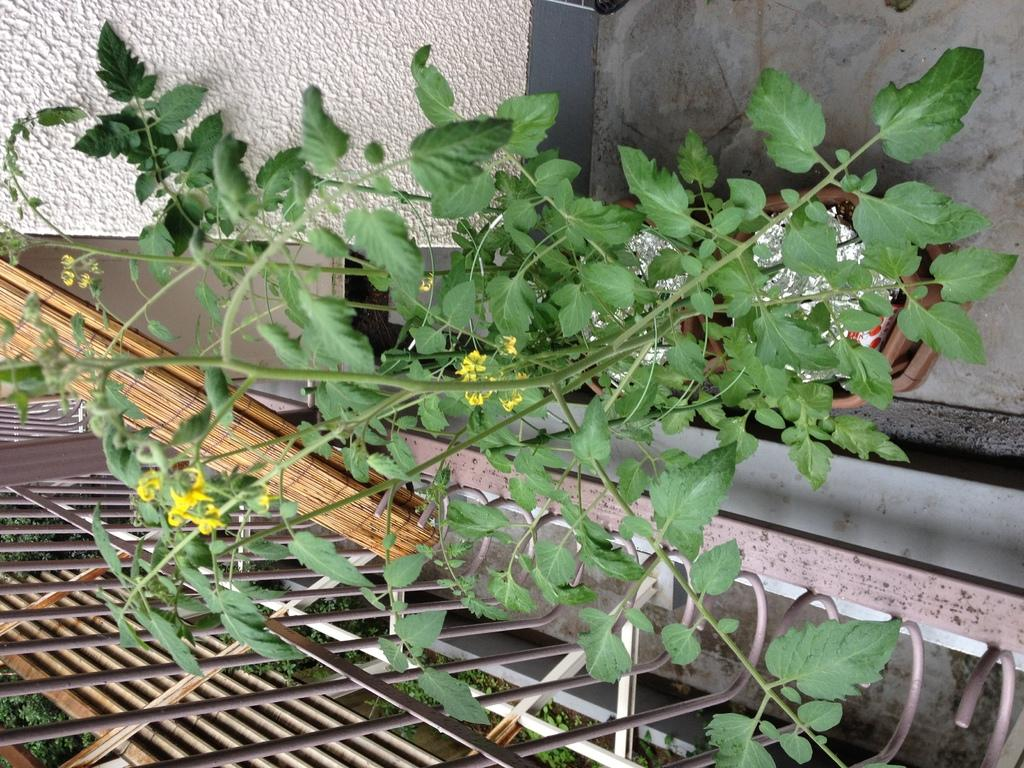What type of living organism can be seen in the image? There is a plant in the image. What is located at the bottom of the image? There is a mesh at the bottom of the image. What can be seen in the background of the image? There is a wall in the background of the image. How many cherries are hanging from the knot in the image? There is no knot or cherries present in the image. 